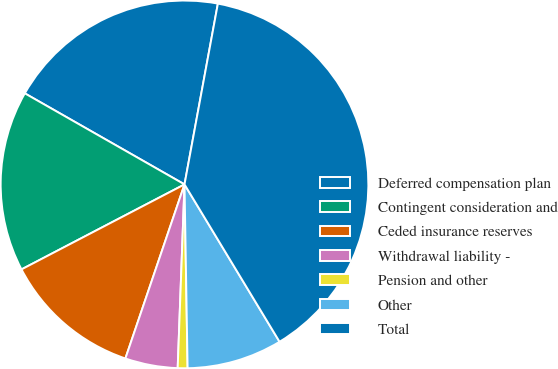Convert chart to OTSL. <chart><loc_0><loc_0><loc_500><loc_500><pie_chart><fcel>Deferred compensation plan<fcel>Contingent consideration and<fcel>Ceded insurance reserves<fcel>Withdrawal liability -<fcel>Pension and other<fcel>Other<fcel>Total<nl><fcel>19.66%<fcel>15.9%<fcel>12.14%<fcel>4.62%<fcel>0.86%<fcel>8.38%<fcel>38.45%<nl></chart> 